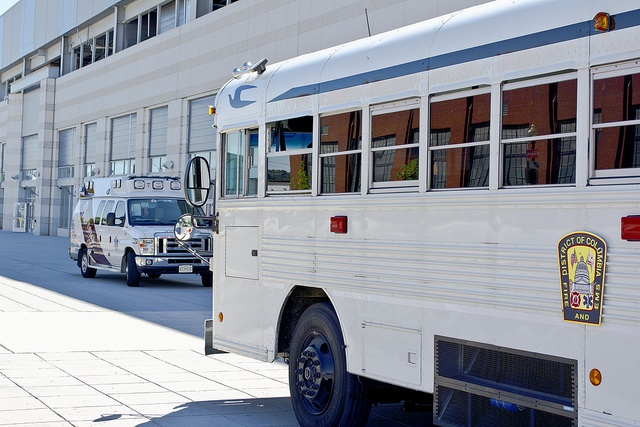Describe the objects in this image and their specific colors. I can see bus in white, darkgray, lightgray, and black tones, truck in lightblue, darkgray, black, and gray tones, and bird in white, gray, darkgray, and lightblue tones in this image. 